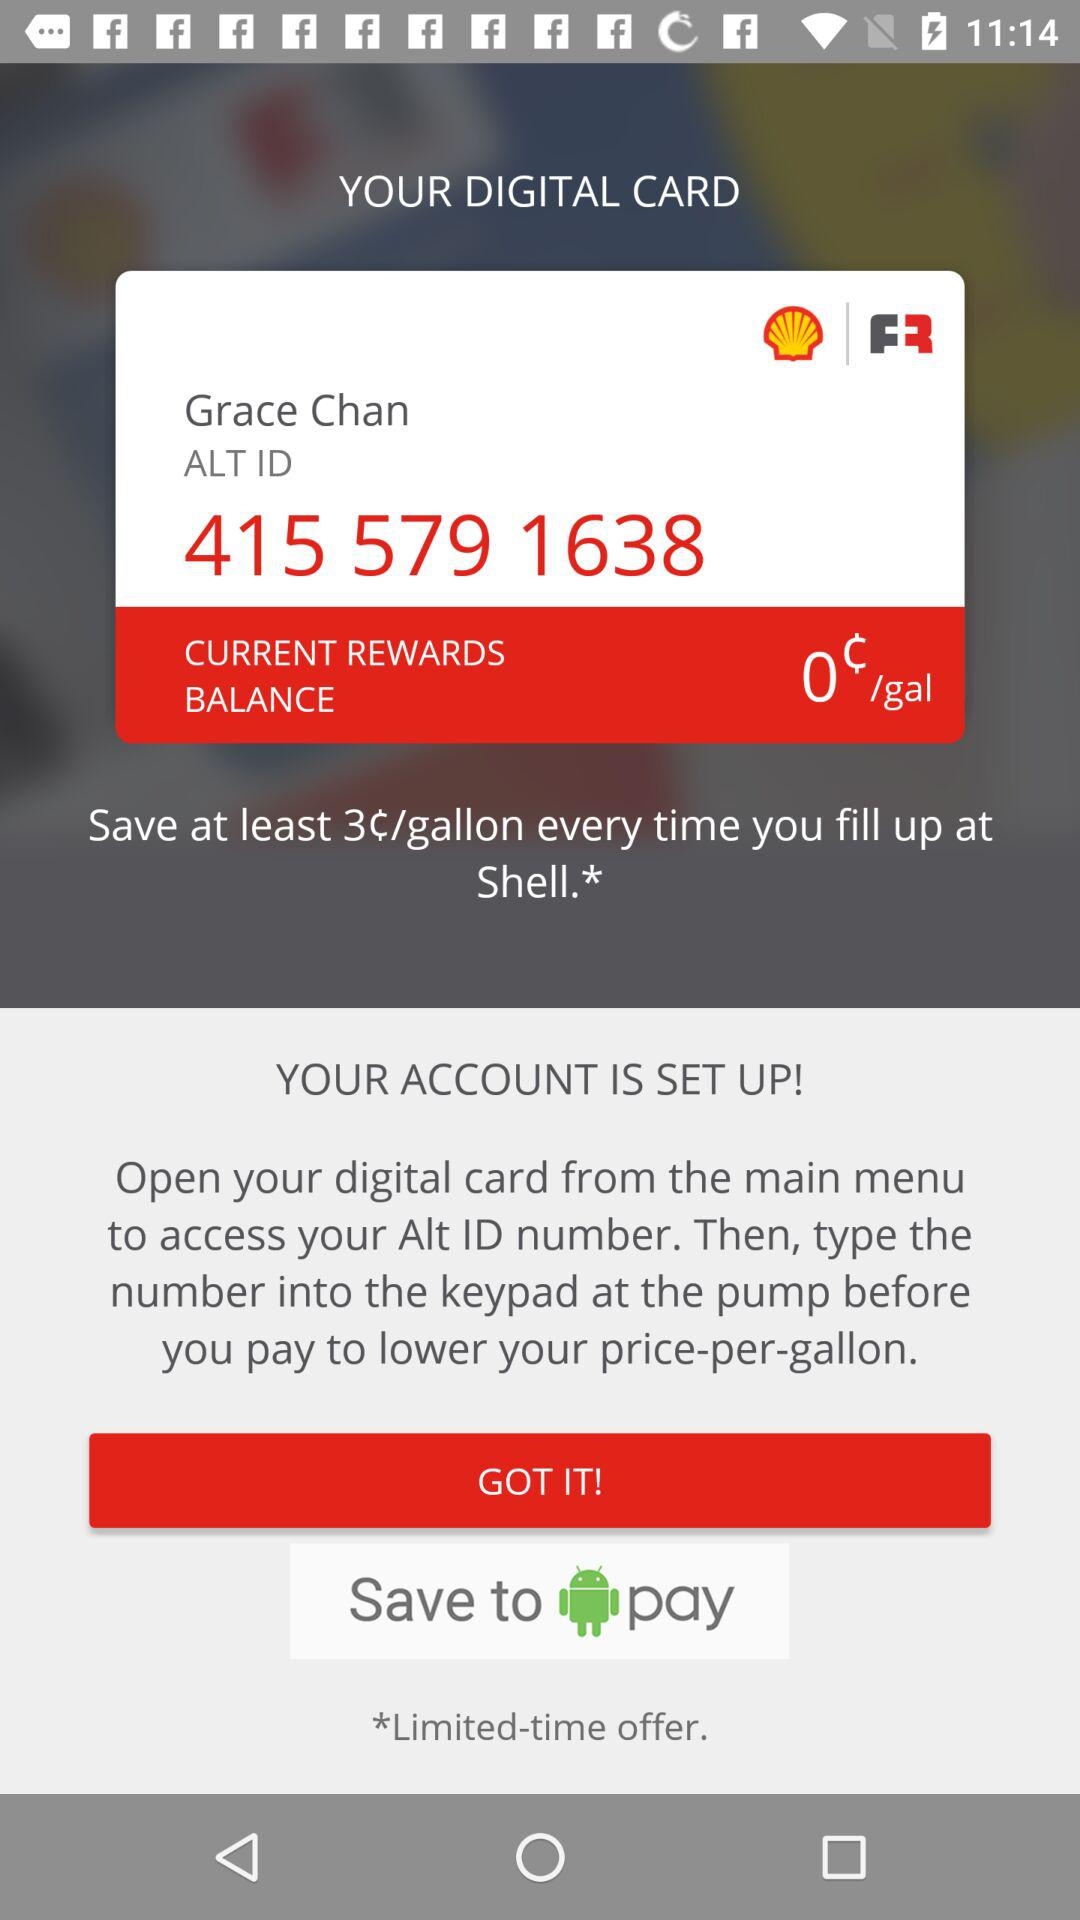What is the number on the card? The number on the card is 415 579 1638. 